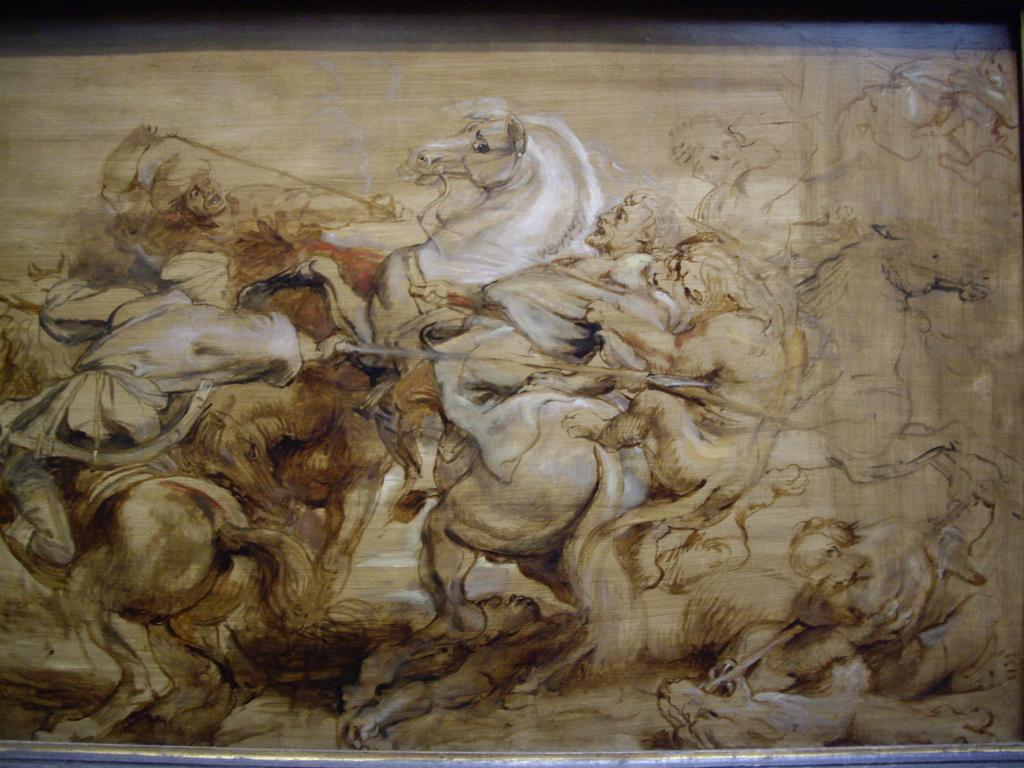What is the main subject of the image? There is a painting in the image. What colors are predominant in the painting? The painting has brown and cream colors. What is depicted in the painting? The painting depicts animals and persons. Can you tell me how many beggars are depicted in the painting? There is no beggar present in the painting; it depicts animals and persons. What type of corn can be seen growing along the coast in the painting? There is no corn or coast depicted in the painting; it features of the painting include animals and persons. 